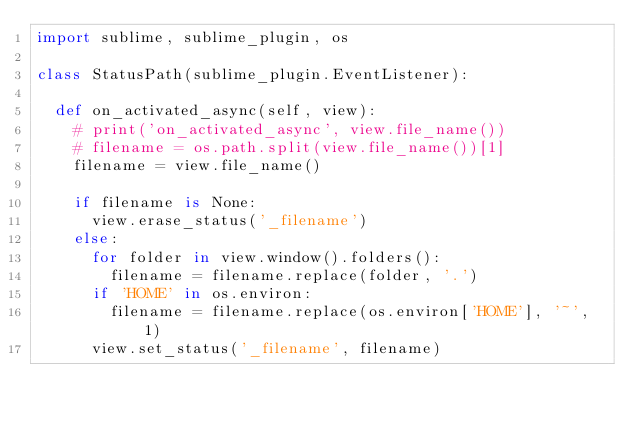<code> <loc_0><loc_0><loc_500><loc_500><_Python_>import sublime, sublime_plugin, os

class StatusPath(sublime_plugin.EventListener):
  
  def on_activated_async(self, view):
    # print('on_activated_async', view.file_name())
    # filename = os.path.split(view.file_name())[1]
    filename = view.file_name()

    if filename is None:
      view.erase_status('_filename')
    else:
      for folder in view.window().folders():
        filename = filename.replace(folder, '.')
      if 'HOME' in os.environ:
        filename = filename.replace(os.environ['HOME'], '~', 1)
      view.set_status('_filename', filename)
</code> 